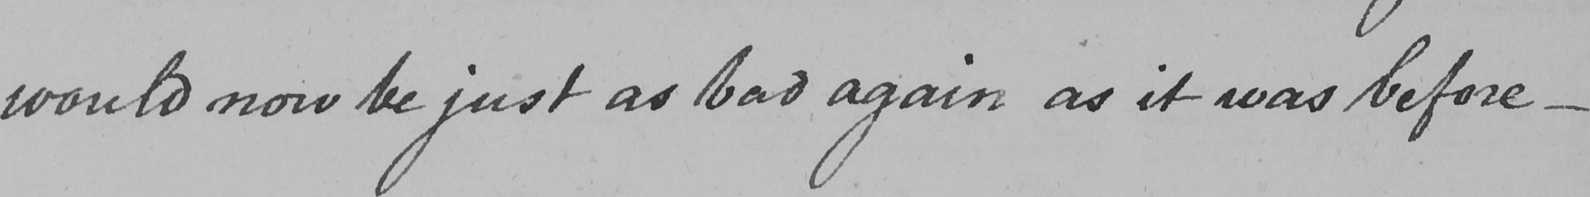Can you read and transcribe this handwriting? would now be just as bad again as it was before _ 